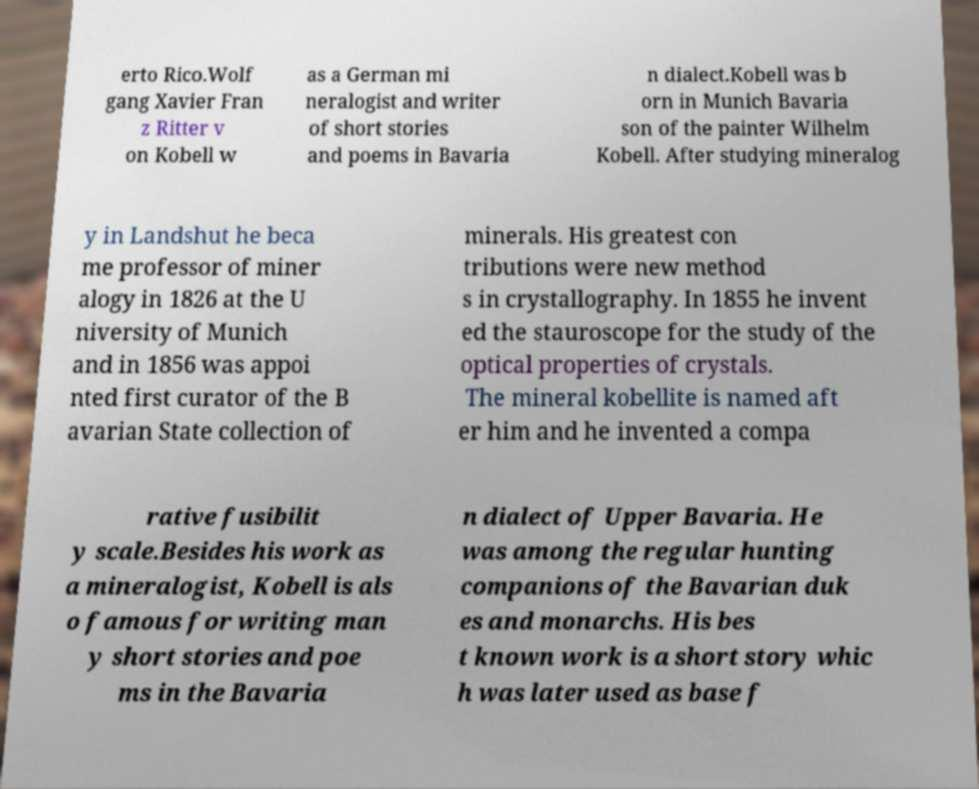For documentation purposes, I need the text within this image transcribed. Could you provide that? erto Rico.Wolf gang Xavier Fran z Ritter v on Kobell w as a German mi neralogist and writer of short stories and poems in Bavaria n dialect.Kobell was b orn in Munich Bavaria son of the painter Wilhelm Kobell. After studying mineralog y in Landshut he beca me professor of miner alogy in 1826 at the U niversity of Munich and in 1856 was appoi nted first curator of the B avarian State collection of minerals. His greatest con tributions were new method s in crystallography. In 1855 he invent ed the stauroscope for the study of the optical properties of crystals. The mineral kobellite is named aft er him and he invented a compa rative fusibilit y scale.Besides his work as a mineralogist, Kobell is als o famous for writing man y short stories and poe ms in the Bavaria n dialect of Upper Bavaria. He was among the regular hunting companions of the Bavarian duk es and monarchs. His bes t known work is a short story whic h was later used as base f 